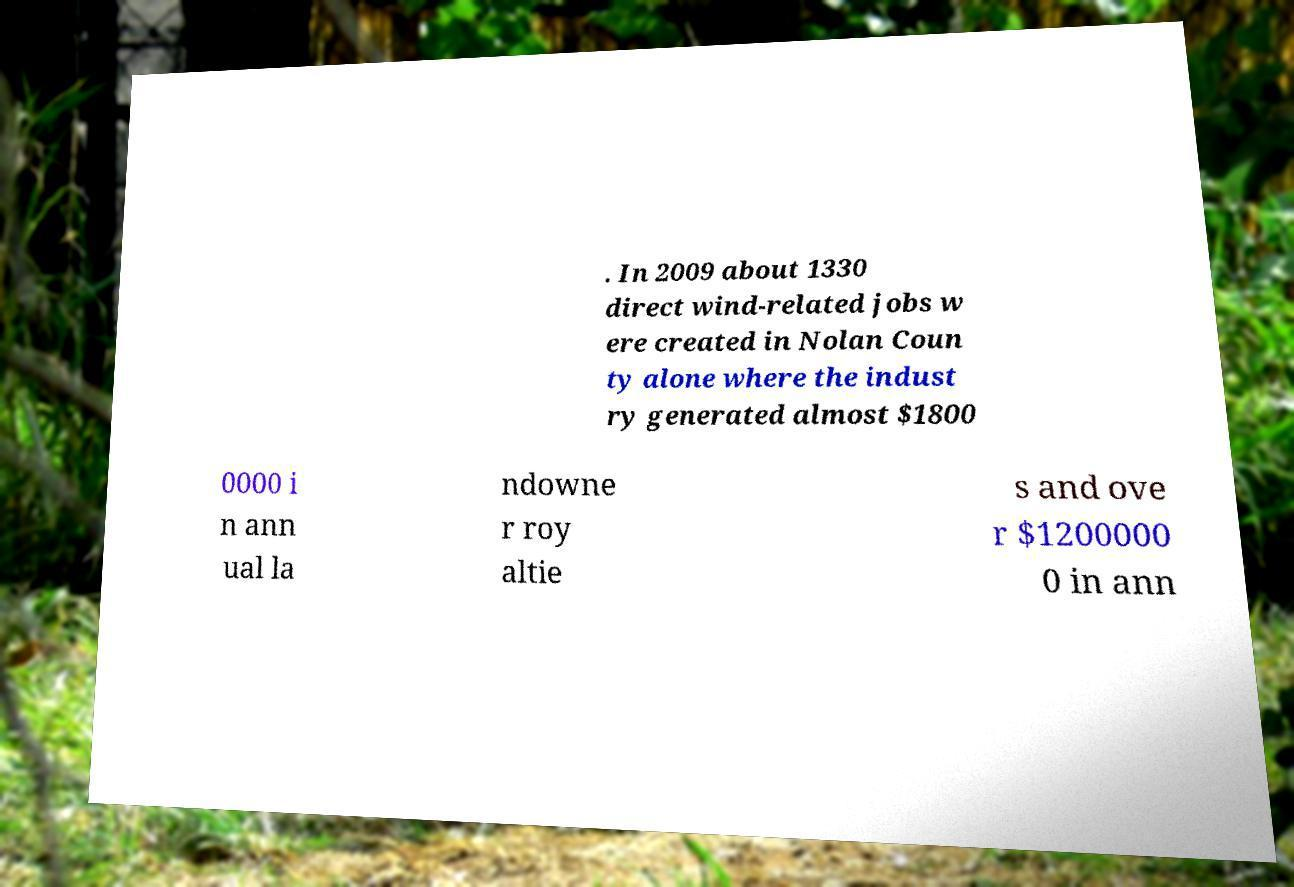There's text embedded in this image that I need extracted. Can you transcribe it verbatim? . In 2009 about 1330 direct wind-related jobs w ere created in Nolan Coun ty alone where the indust ry generated almost $1800 0000 i n ann ual la ndowne r roy altie s and ove r $1200000 0 in ann 